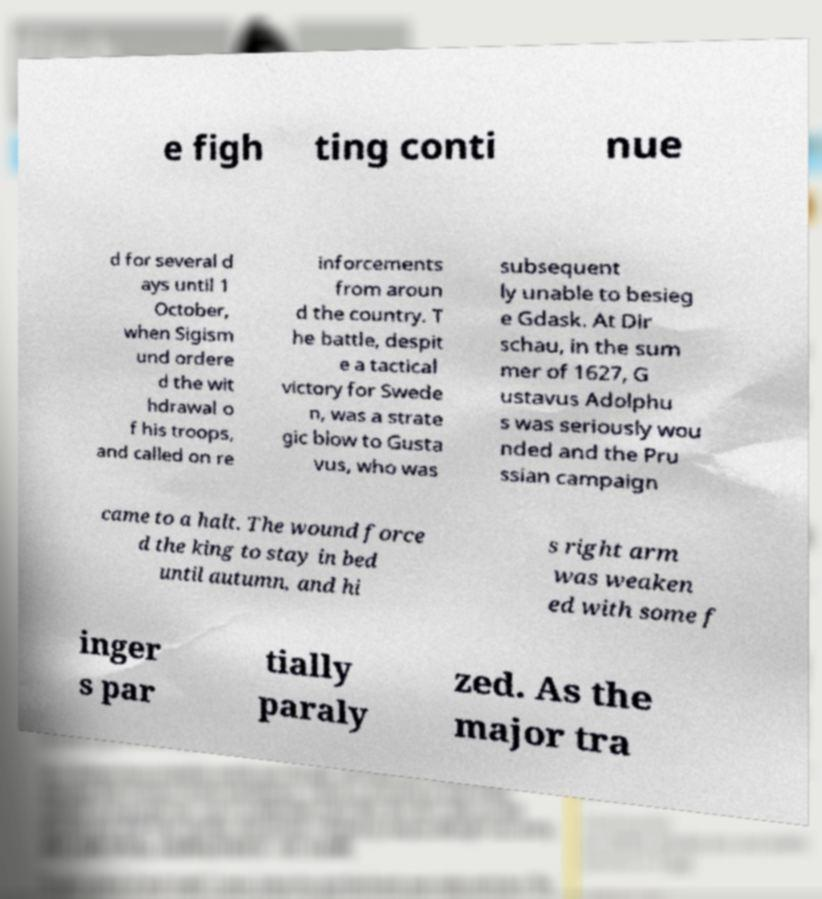I need the written content from this picture converted into text. Can you do that? e figh ting conti nue d for several d ays until 1 October, when Sigism und ordere d the wit hdrawal o f his troops, and called on re inforcements from aroun d the country. T he battle, despit e a tactical victory for Swede n, was a strate gic blow to Gusta vus, who was subsequent ly unable to besieg e Gdask. At Dir schau, in the sum mer of 1627, G ustavus Adolphu s was seriously wou nded and the Pru ssian campaign came to a halt. The wound force d the king to stay in bed until autumn, and hi s right arm was weaken ed with some f inger s par tially paraly zed. As the major tra 